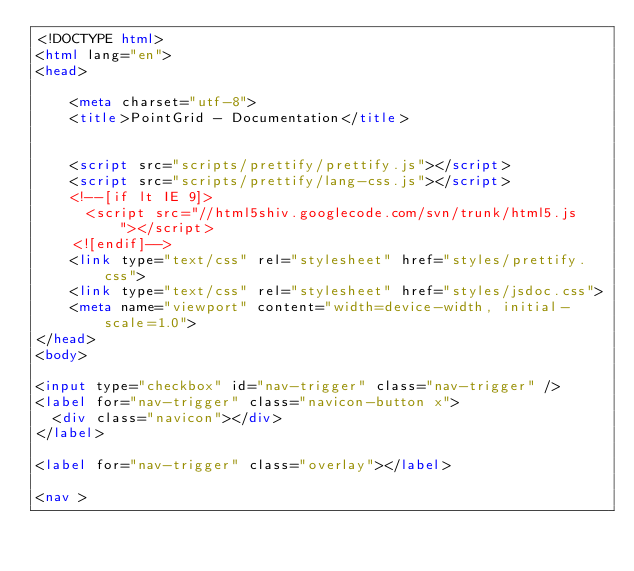<code> <loc_0><loc_0><loc_500><loc_500><_HTML_><!DOCTYPE html>
<html lang="en">
<head>
    
    <meta charset="utf-8">
    <title>PointGrid - Documentation</title>
    
    
    <script src="scripts/prettify/prettify.js"></script>
    <script src="scripts/prettify/lang-css.js"></script>
    <!--[if lt IE 9]>
      <script src="//html5shiv.googlecode.com/svn/trunk/html5.js"></script>
    <![endif]-->
    <link type="text/css" rel="stylesheet" href="styles/prettify.css">
    <link type="text/css" rel="stylesheet" href="styles/jsdoc.css">
    <meta name="viewport" content="width=device-width, initial-scale=1.0">
</head>
<body>

<input type="checkbox" id="nav-trigger" class="nav-trigger" />
<label for="nav-trigger" class="navicon-button x">
  <div class="navicon"></div>
</label>

<label for="nav-trigger" class="overlay"></label>

<nav >
    </code> 